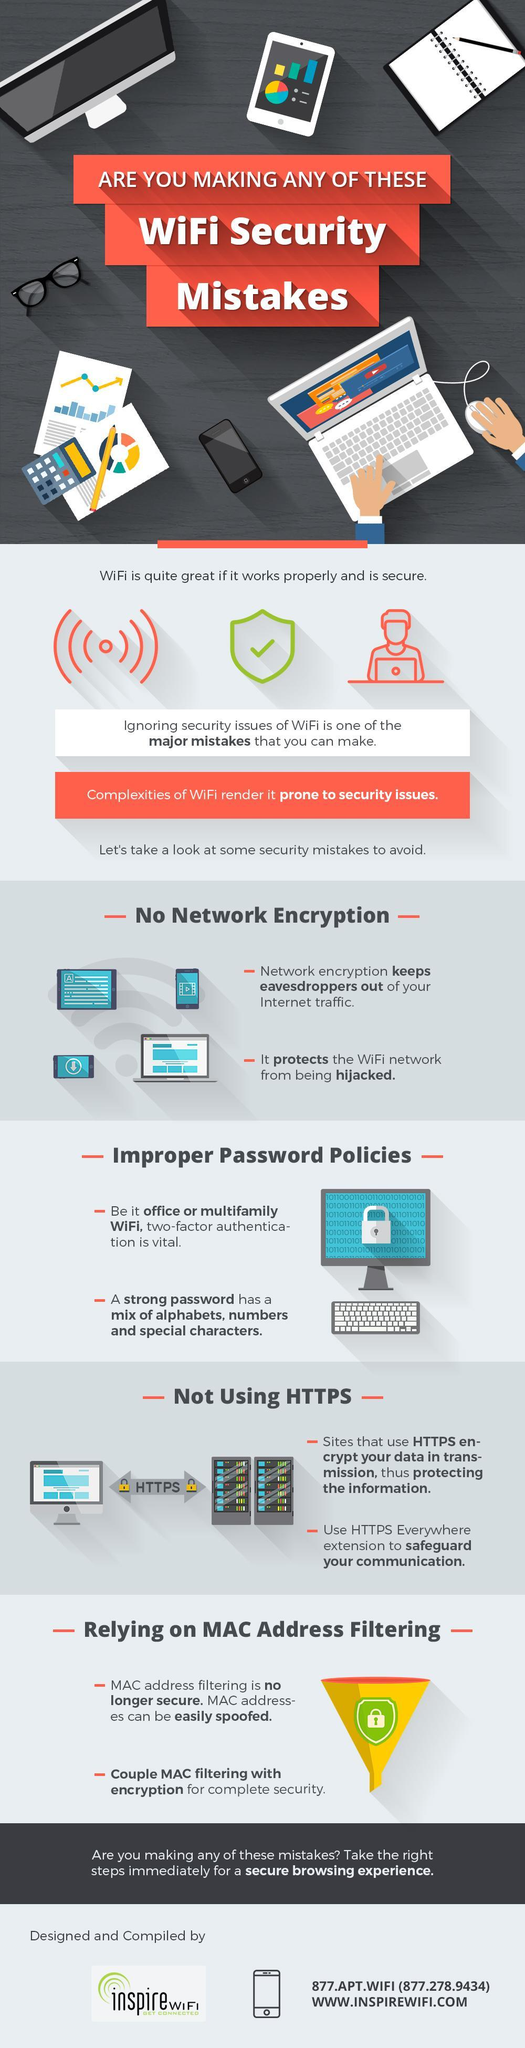Other than special characters and mix of alphabets what else is required to make a strong password
Answer the question with a short phrase. numbers what is the colour of the lock on either side of HTTPS, yellow or grey yellow what is the colour of the funnel, green or yellow yellow Eavesdropping and hijacking happen due to lack of what no network encryption 